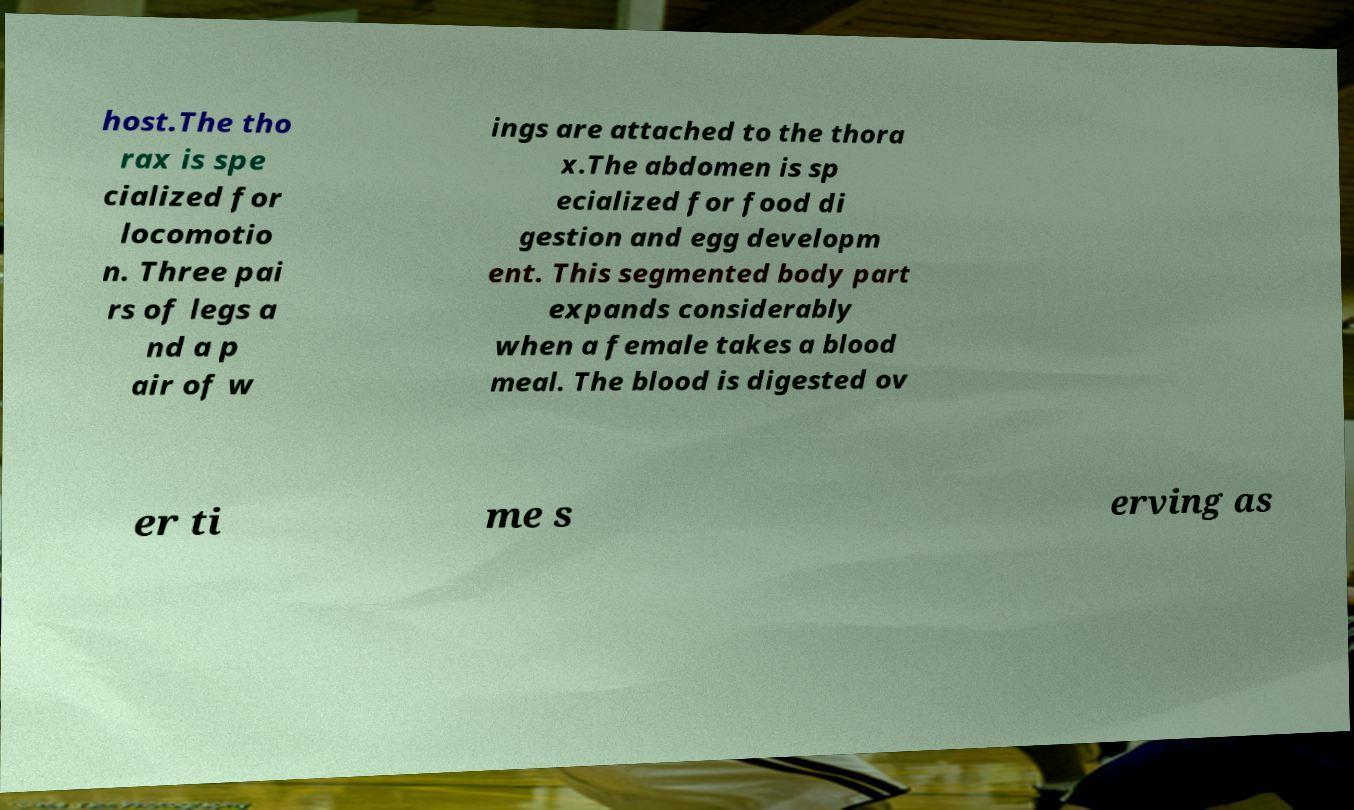Can you read and provide the text displayed in the image?This photo seems to have some interesting text. Can you extract and type it out for me? host.The tho rax is spe cialized for locomotio n. Three pai rs of legs a nd a p air of w ings are attached to the thora x.The abdomen is sp ecialized for food di gestion and egg developm ent. This segmented body part expands considerably when a female takes a blood meal. The blood is digested ov er ti me s erving as 